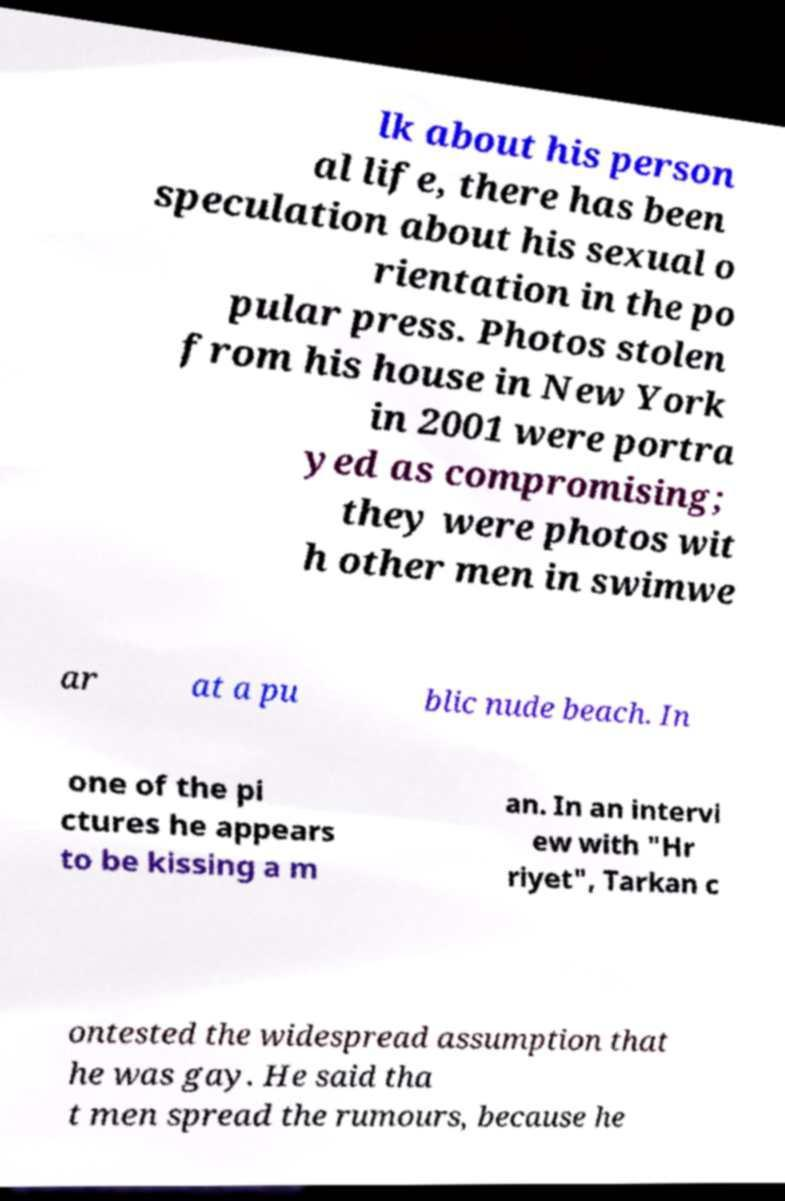Could you extract and type out the text from this image? lk about his person al life, there has been speculation about his sexual o rientation in the po pular press. Photos stolen from his house in New York in 2001 were portra yed as compromising; they were photos wit h other men in swimwe ar at a pu blic nude beach. In one of the pi ctures he appears to be kissing a m an. In an intervi ew with "Hr riyet", Tarkan c ontested the widespread assumption that he was gay. He said tha t men spread the rumours, because he 